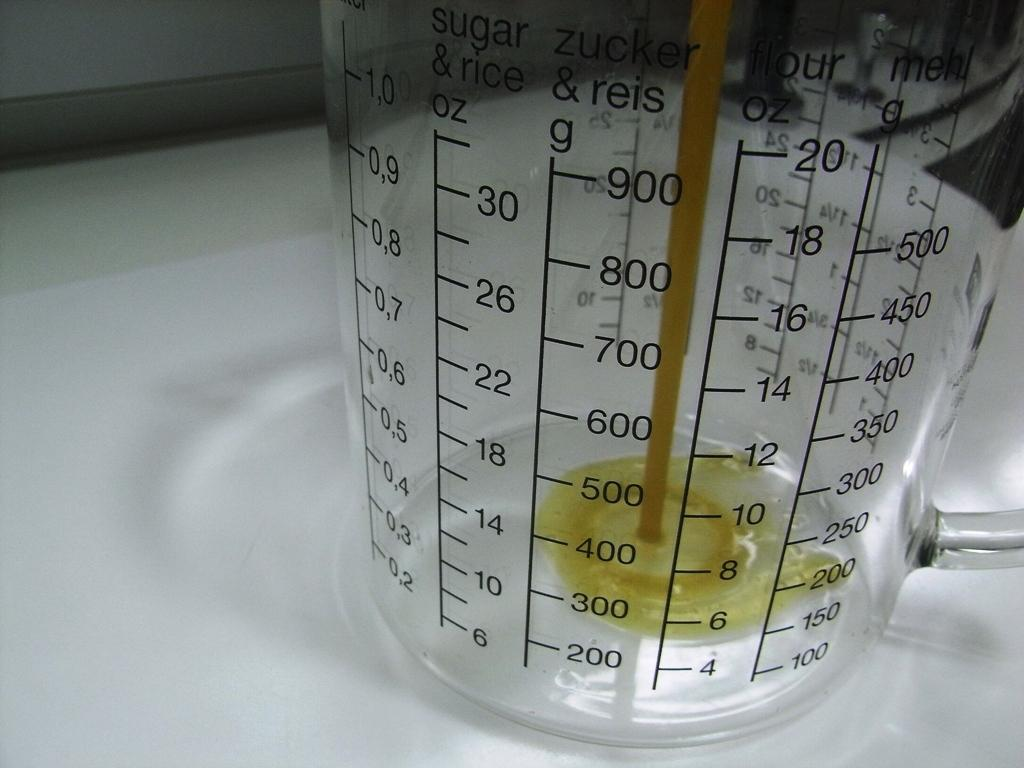<image>
Describe the image concisely. the numbers 500 and 600 are on a measuring cup 